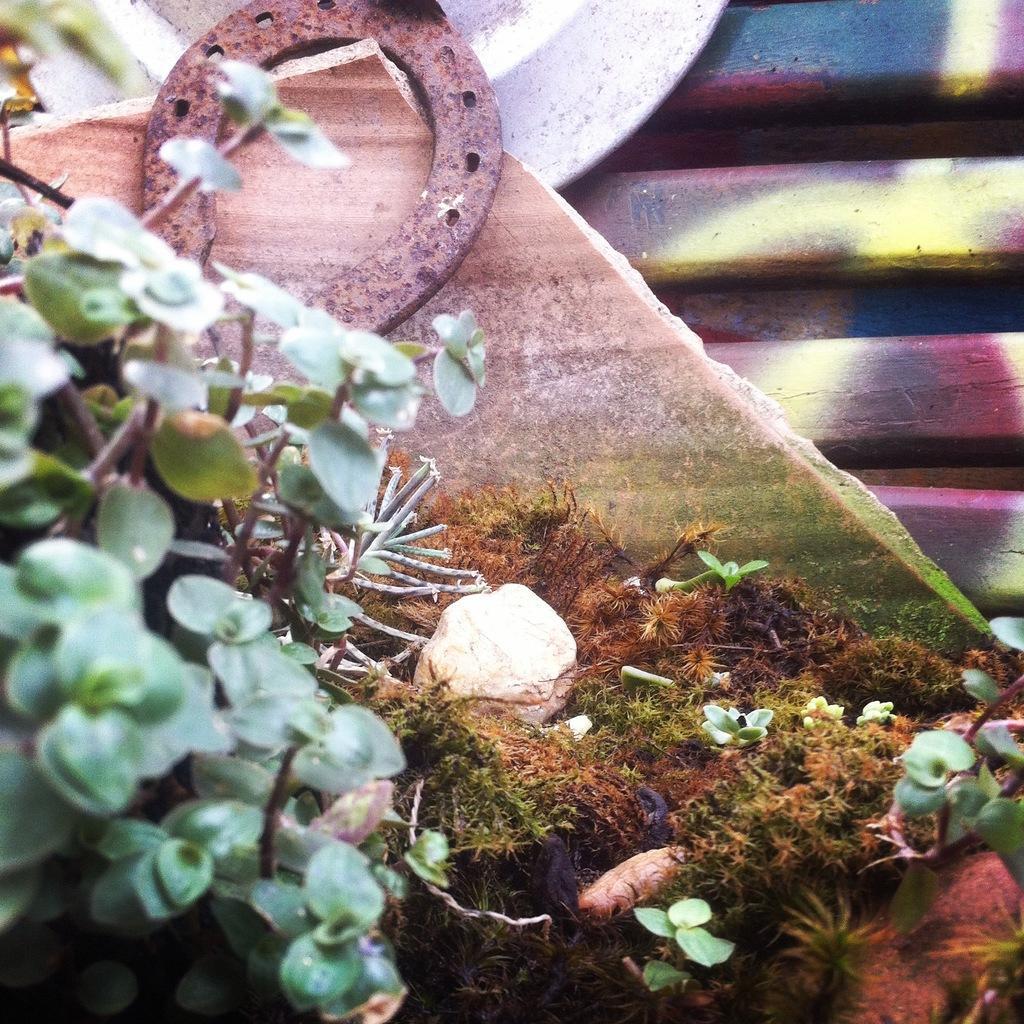Please provide a concise description of this image. In this picture we can see plants, stone, a marble piece, a rusted item and other items. 